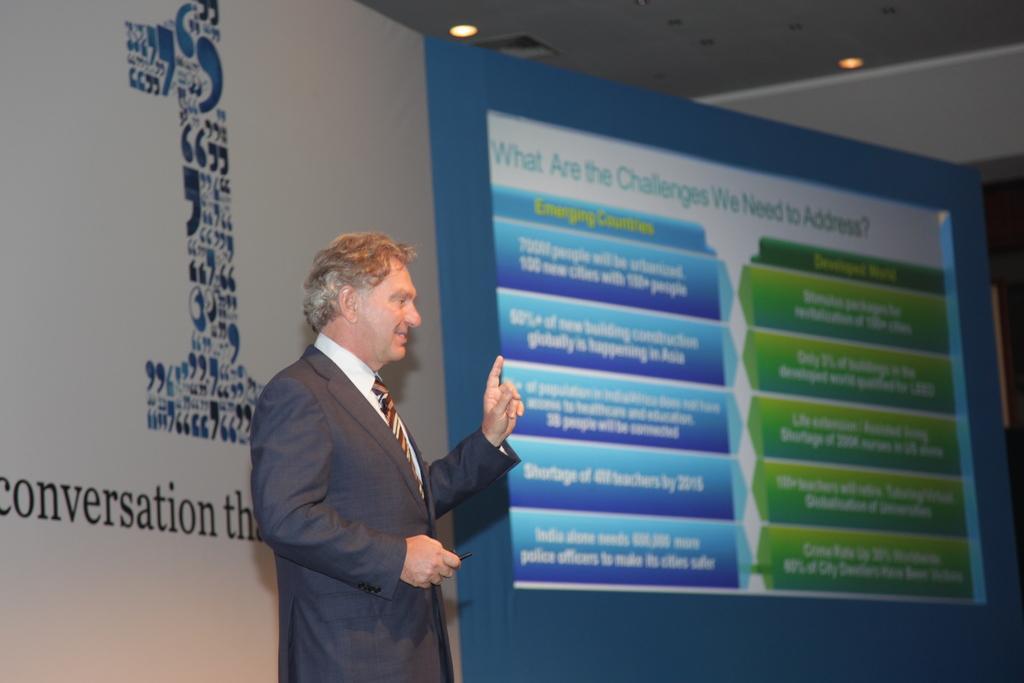Could you give a brief overview of what you see in this image? In this picture there is a man who is wearing suit and he is standing near to the advertisement board. On the left we can see projector screen on the wall. At the top we can see lights and ducts. 